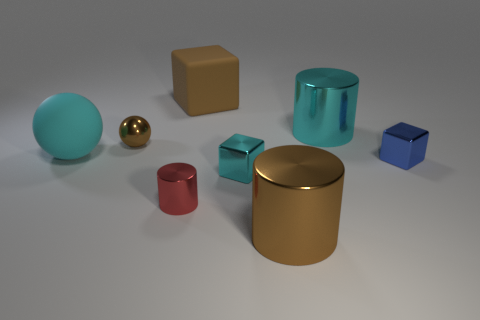There is a brown object that is the same shape as the small cyan object; what size is it?
Ensure brevity in your answer.  Large. There is a metallic block that is in front of the tiny block to the right of the tiny cyan cube; what number of balls are in front of it?
Your answer should be very brief. 0. What color is the tiny metallic thing behind the tiny object that is to the right of the big cyan cylinder?
Keep it short and to the point. Brown. How many other objects are there of the same material as the tiny ball?
Your answer should be compact. 5. There is a large cyan object that is on the left side of the red cylinder; how many cyan blocks are in front of it?
Your answer should be compact. 1. Are there any other things that have the same shape as the tiny cyan object?
Your answer should be compact. Yes. There is a large cylinder in front of the brown metallic ball; does it have the same color as the small block on the left side of the big brown shiny cylinder?
Offer a very short reply. No. Is the number of brown balls less than the number of brown things?
Provide a succinct answer. Yes. What shape is the large cyan thing right of the tiny metallic block that is to the left of the blue object?
Offer a very short reply. Cylinder. Is there any other thing that is the same size as the matte sphere?
Offer a terse response. Yes. 